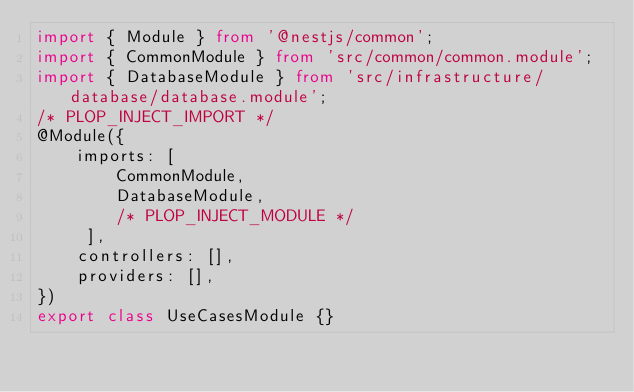Convert code to text. <code><loc_0><loc_0><loc_500><loc_500><_TypeScript_>import { Module } from '@nestjs/common';
import { CommonModule } from 'src/common/common.module';
import { DatabaseModule } from 'src/infrastructure/database/database.module';
/* PLOP_INJECT_IMPORT */
@Module({
    imports: [
        CommonModule,
        DatabaseModule,
        /* PLOP_INJECT_MODULE */
     ],
    controllers: [],
    providers: [],
})
export class UseCasesModule {}</code> 